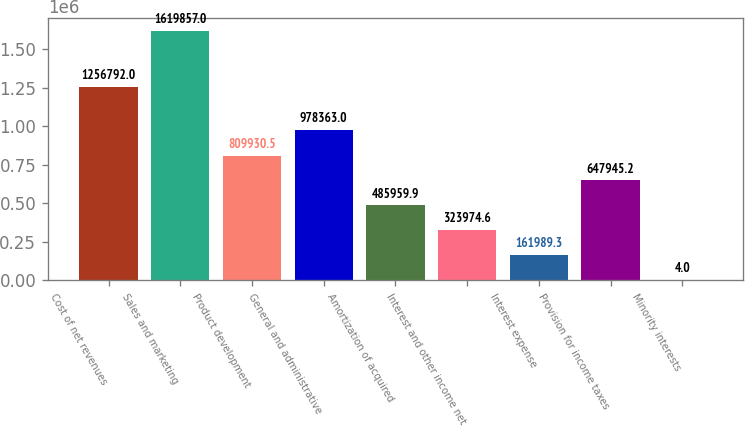Convert chart. <chart><loc_0><loc_0><loc_500><loc_500><bar_chart><fcel>Cost of net revenues<fcel>Sales and marketing<fcel>Product development<fcel>General and administrative<fcel>Amortization of acquired<fcel>Interest and other income net<fcel>Interest expense<fcel>Provision for income taxes<fcel>Minority interests<nl><fcel>1.25679e+06<fcel>1.61986e+06<fcel>809930<fcel>978363<fcel>485960<fcel>323975<fcel>161989<fcel>647945<fcel>4<nl></chart> 